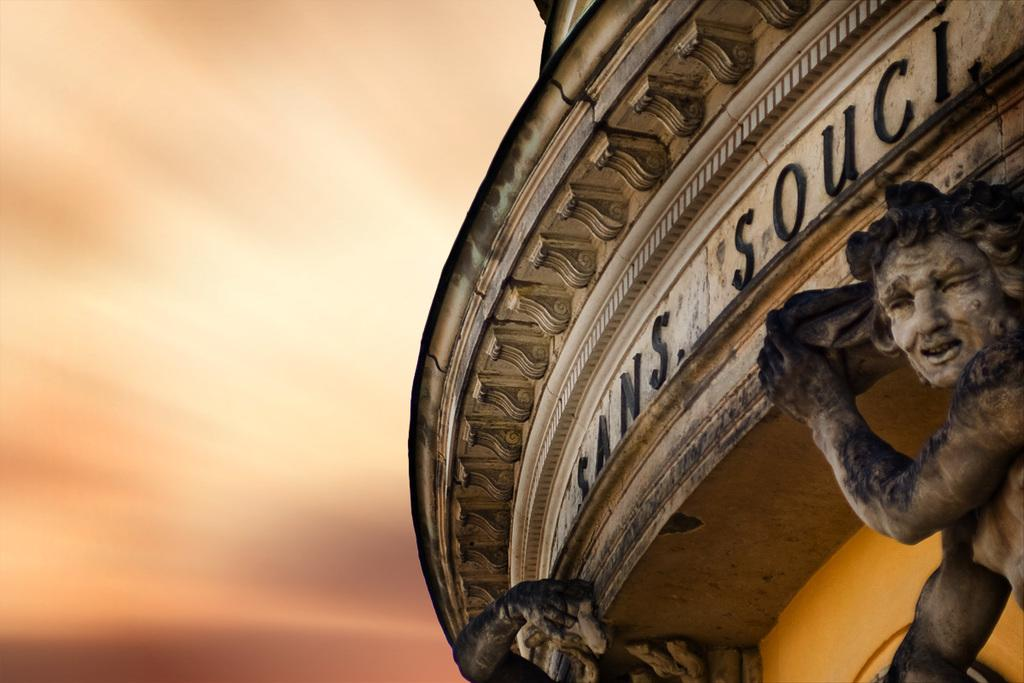What can be seen in the image besides the building? There are statues in the image. Where are the statues located in relation to the building? The statues are near the building. What colors are used for the building in the image? The building is in cream and black color. Can you describe the background of the image? The background of the image is blurred. How many frogs are sitting on the statues in the image? There are no frogs present in the image; it only features statues and a building. 